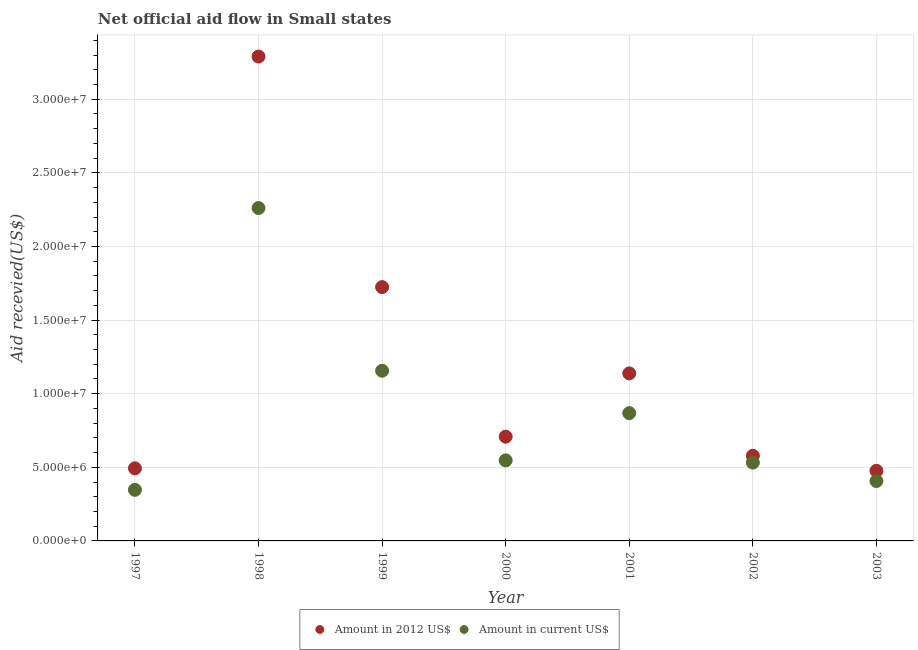Is the number of dotlines equal to the number of legend labels?
Your answer should be compact. Yes. What is the amount of aid received(expressed in us$) in 1998?
Make the answer very short. 2.26e+07. Across all years, what is the maximum amount of aid received(expressed in us$)?
Offer a terse response. 2.26e+07. Across all years, what is the minimum amount of aid received(expressed in 2012 us$)?
Keep it short and to the point. 4.76e+06. What is the total amount of aid received(expressed in 2012 us$) in the graph?
Offer a terse response. 8.41e+07. What is the difference between the amount of aid received(expressed in 2012 us$) in 1999 and that in 2000?
Your response must be concise. 1.02e+07. What is the difference between the amount of aid received(expressed in 2012 us$) in 2003 and the amount of aid received(expressed in us$) in 2001?
Your response must be concise. -3.92e+06. What is the average amount of aid received(expressed in 2012 us$) per year?
Offer a terse response. 1.20e+07. In the year 1997, what is the difference between the amount of aid received(expressed in 2012 us$) and amount of aid received(expressed in us$)?
Your answer should be compact. 1.46e+06. What is the ratio of the amount of aid received(expressed in 2012 us$) in 1997 to that in 2001?
Your response must be concise. 0.43. What is the difference between the highest and the second highest amount of aid received(expressed in us$)?
Your response must be concise. 1.10e+07. What is the difference between the highest and the lowest amount of aid received(expressed in 2012 us$)?
Provide a succinct answer. 2.81e+07. In how many years, is the amount of aid received(expressed in us$) greater than the average amount of aid received(expressed in us$) taken over all years?
Offer a terse response. 2. Does the amount of aid received(expressed in 2012 us$) monotonically increase over the years?
Offer a very short reply. No. Is the amount of aid received(expressed in 2012 us$) strictly greater than the amount of aid received(expressed in us$) over the years?
Give a very brief answer. Yes. Does the graph contain any zero values?
Your answer should be compact. No. Where does the legend appear in the graph?
Provide a succinct answer. Bottom center. How many legend labels are there?
Your answer should be very brief. 2. How are the legend labels stacked?
Offer a terse response. Horizontal. What is the title of the graph?
Your answer should be very brief. Net official aid flow in Small states. Does "External balance on goods" appear as one of the legend labels in the graph?
Offer a very short reply. No. What is the label or title of the X-axis?
Keep it short and to the point. Year. What is the label or title of the Y-axis?
Your response must be concise. Aid recevied(US$). What is the Aid recevied(US$) in Amount in 2012 US$ in 1997?
Your response must be concise. 4.93e+06. What is the Aid recevied(US$) of Amount in current US$ in 1997?
Your answer should be very brief. 3.47e+06. What is the Aid recevied(US$) of Amount in 2012 US$ in 1998?
Ensure brevity in your answer.  3.29e+07. What is the Aid recevied(US$) of Amount in current US$ in 1998?
Your answer should be very brief. 2.26e+07. What is the Aid recevied(US$) of Amount in 2012 US$ in 1999?
Provide a short and direct response. 1.72e+07. What is the Aid recevied(US$) in Amount in current US$ in 1999?
Give a very brief answer. 1.16e+07. What is the Aid recevied(US$) in Amount in 2012 US$ in 2000?
Offer a terse response. 7.08e+06. What is the Aid recevied(US$) of Amount in current US$ in 2000?
Make the answer very short. 5.47e+06. What is the Aid recevied(US$) in Amount in 2012 US$ in 2001?
Offer a terse response. 1.14e+07. What is the Aid recevied(US$) of Amount in current US$ in 2001?
Ensure brevity in your answer.  8.68e+06. What is the Aid recevied(US$) in Amount in 2012 US$ in 2002?
Your answer should be very brief. 5.78e+06. What is the Aid recevied(US$) in Amount in current US$ in 2002?
Ensure brevity in your answer.  5.32e+06. What is the Aid recevied(US$) in Amount in 2012 US$ in 2003?
Your answer should be compact. 4.76e+06. What is the Aid recevied(US$) in Amount in current US$ in 2003?
Your response must be concise. 4.07e+06. Across all years, what is the maximum Aid recevied(US$) in Amount in 2012 US$?
Keep it short and to the point. 3.29e+07. Across all years, what is the maximum Aid recevied(US$) in Amount in current US$?
Offer a very short reply. 2.26e+07. Across all years, what is the minimum Aid recevied(US$) in Amount in 2012 US$?
Your response must be concise. 4.76e+06. Across all years, what is the minimum Aid recevied(US$) in Amount in current US$?
Give a very brief answer. 3.47e+06. What is the total Aid recevied(US$) of Amount in 2012 US$ in the graph?
Offer a terse response. 8.41e+07. What is the total Aid recevied(US$) of Amount in current US$ in the graph?
Your response must be concise. 6.12e+07. What is the difference between the Aid recevied(US$) in Amount in 2012 US$ in 1997 and that in 1998?
Offer a terse response. -2.80e+07. What is the difference between the Aid recevied(US$) in Amount in current US$ in 1997 and that in 1998?
Provide a succinct answer. -1.91e+07. What is the difference between the Aid recevied(US$) in Amount in 2012 US$ in 1997 and that in 1999?
Give a very brief answer. -1.23e+07. What is the difference between the Aid recevied(US$) in Amount in current US$ in 1997 and that in 1999?
Provide a short and direct response. -8.09e+06. What is the difference between the Aid recevied(US$) in Amount in 2012 US$ in 1997 and that in 2000?
Offer a terse response. -2.15e+06. What is the difference between the Aid recevied(US$) in Amount in current US$ in 1997 and that in 2000?
Offer a very short reply. -2.00e+06. What is the difference between the Aid recevied(US$) in Amount in 2012 US$ in 1997 and that in 2001?
Give a very brief answer. -6.45e+06. What is the difference between the Aid recevied(US$) in Amount in current US$ in 1997 and that in 2001?
Ensure brevity in your answer.  -5.21e+06. What is the difference between the Aid recevied(US$) in Amount in 2012 US$ in 1997 and that in 2002?
Keep it short and to the point. -8.50e+05. What is the difference between the Aid recevied(US$) of Amount in current US$ in 1997 and that in 2002?
Ensure brevity in your answer.  -1.85e+06. What is the difference between the Aid recevied(US$) of Amount in 2012 US$ in 1997 and that in 2003?
Keep it short and to the point. 1.70e+05. What is the difference between the Aid recevied(US$) in Amount in current US$ in 1997 and that in 2003?
Your answer should be very brief. -6.00e+05. What is the difference between the Aid recevied(US$) in Amount in 2012 US$ in 1998 and that in 1999?
Provide a short and direct response. 1.57e+07. What is the difference between the Aid recevied(US$) in Amount in current US$ in 1998 and that in 1999?
Your answer should be very brief. 1.10e+07. What is the difference between the Aid recevied(US$) of Amount in 2012 US$ in 1998 and that in 2000?
Offer a very short reply. 2.58e+07. What is the difference between the Aid recevied(US$) in Amount in current US$ in 1998 and that in 2000?
Your answer should be very brief. 1.71e+07. What is the difference between the Aid recevied(US$) in Amount in 2012 US$ in 1998 and that in 2001?
Keep it short and to the point. 2.15e+07. What is the difference between the Aid recevied(US$) of Amount in current US$ in 1998 and that in 2001?
Keep it short and to the point. 1.39e+07. What is the difference between the Aid recevied(US$) of Amount in 2012 US$ in 1998 and that in 2002?
Make the answer very short. 2.71e+07. What is the difference between the Aid recevied(US$) of Amount in current US$ in 1998 and that in 2002?
Provide a short and direct response. 1.73e+07. What is the difference between the Aid recevied(US$) in Amount in 2012 US$ in 1998 and that in 2003?
Your answer should be very brief. 2.81e+07. What is the difference between the Aid recevied(US$) of Amount in current US$ in 1998 and that in 2003?
Give a very brief answer. 1.85e+07. What is the difference between the Aid recevied(US$) in Amount in 2012 US$ in 1999 and that in 2000?
Give a very brief answer. 1.02e+07. What is the difference between the Aid recevied(US$) of Amount in current US$ in 1999 and that in 2000?
Your answer should be very brief. 6.09e+06. What is the difference between the Aid recevied(US$) of Amount in 2012 US$ in 1999 and that in 2001?
Your answer should be compact. 5.86e+06. What is the difference between the Aid recevied(US$) in Amount in current US$ in 1999 and that in 2001?
Your answer should be very brief. 2.88e+06. What is the difference between the Aid recevied(US$) in Amount in 2012 US$ in 1999 and that in 2002?
Offer a terse response. 1.15e+07. What is the difference between the Aid recevied(US$) of Amount in current US$ in 1999 and that in 2002?
Keep it short and to the point. 6.24e+06. What is the difference between the Aid recevied(US$) of Amount in 2012 US$ in 1999 and that in 2003?
Ensure brevity in your answer.  1.25e+07. What is the difference between the Aid recevied(US$) in Amount in current US$ in 1999 and that in 2003?
Your answer should be compact. 7.49e+06. What is the difference between the Aid recevied(US$) of Amount in 2012 US$ in 2000 and that in 2001?
Make the answer very short. -4.30e+06. What is the difference between the Aid recevied(US$) in Amount in current US$ in 2000 and that in 2001?
Keep it short and to the point. -3.21e+06. What is the difference between the Aid recevied(US$) in Amount in 2012 US$ in 2000 and that in 2002?
Provide a short and direct response. 1.30e+06. What is the difference between the Aid recevied(US$) of Amount in 2012 US$ in 2000 and that in 2003?
Your answer should be compact. 2.32e+06. What is the difference between the Aid recevied(US$) in Amount in current US$ in 2000 and that in 2003?
Offer a very short reply. 1.40e+06. What is the difference between the Aid recevied(US$) of Amount in 2012 US$ in 2001 and that in 2002?
Your response must be concise. 5.60e+06. What is the difference between the Aid recevied(US$) in Amount in current US$ in 2001 and that in 2002?
Provide a succinct answer. 3.36e+06. What is the difference between the Aid recevied(US$) of Amount in 2012 US$ in 2001 and that in 2003?
Provide a short and direct response. 6.62e+06. What is the difference between the Aid recevied(US$) in Amount in current US$ in 2001 and that in 2003?
Provide a succinct answer. 4.61e+06. What is the difference between the Aid recevied(US$) of Amount in 2012 US$ in 2002 and that in 2003?
Offer a terse response. 1.02e+06. What is the difference between the Aid recevied(US$) in Amount in current US$ in 2002 and that in 2003?
Provide a succinct answer. 1.25e+06. What is the difference between the Aid recevied(US$) of Amount in 2012 US$ in 1997 and the Aid recevied(US$) of Amount in current US$ in 1998?
Offer a very short reply. -1.77e+07. What is the difference between the Aid recevied(US$) in Amount in 2012 US$ in 1997 and the Aid recevied(US$) in Amount in current US$ in 1999?
Offer a terse response. -6.63e+06. What is the difference between the Aid recevied(US$) in Amount in 2012 US$ in 1997 and the Aid recevied(US$) in Amount in current US$ in 2000?
Make the answer very short. -5.40e+05. What is the difference between the Aid recevied(US$) of Amount in 2012 US$ in 1997 and the Aid recevied(US$) of Amount in current US$ in 2001?
Keep it short and to the point. -3.75e+06. What is the difference between the Aid recevied(US$) in Amount in 2012 US$ in 1997 and the Aid recevied(US$) in Amount in current US$ in 2002?
Make the answer very short. -3.90e+05. What is the difference between the Aid recevied(US$) in Amount in 2012 US$ in 1997 and the Aid recevied(US$) in Amount in current US$ in 2003?
Your answer should be very brief. 8.60e+05. What is the difference between the Aid recevied(US$) in Amount in 2012 US$ in 1998 and the Aid recevied(US$) in Amount in current US$ in 1999?
Your answer should be very brief. 2.13e+07. What is the difference between the Aid recevied(US$) of Amount in 2012 US$ in 1998 and the Aid recevied(US$) of Amount in current US$ in 2000?
Offer a terse response. 2.74e+07. What is the difference between the Aid recevied(US$) of Amount in 2012 US$ in 1998 and the Aid recevied(US$) of Amount in current US$ in 2001?
Provide a short and direct response. 2.42e+07. What is the difference between the Aid recevied(US$) of Amount in 2012 US$ in 1998 and the Aid recevied(US$) of Amount in current US$ in 2002?
Make the answer very short. 2.76e+07. What is the difference between the Aid recevied(US$) of Amount in 2012 US$ in 1998 and the Aid recevied(US$) of Amount in current US$ in 2003?
Offer a very short reply. 2.88e+07. What is the difference between the Aid recevied(US$) of Amount in 2012 US$ in 1999 and the Aid recevied(US$) of Amount in current US$ in 2000?
Keep it short and to the point. 1.18e+07. What is the difference between the Aid recevied(US$) in Amount in 2012 US$ in 1999 and the Aid recevied(US$) in Amount in current US$ in 2001?
Keep it short and to the point. 8.56e+06. What is the difference between the Aid recevied(US$) in Amount in 2012 US$ in 1999 and the Aid recevied(US$) in Amount in current US$ in 2002?
Offer a very short reply. 1.19e+07. What is the difference between the Aid recevied(US$) of Amount in 2012 US$ in 1999 and the Aid recevied(US$) of Amount in current US$ in 2003?
Provide a succinct answer. 1.32e+07. What is the difference between the Aid recevied(US$) of Amount in 2012 US$ in 2000 and the Aid recevied(US$) of Amount in current US$ in 2001?
Keep it short and to the point. -1.60e+06. What is the difference between the Aid recevied(US$) of Amount in 2012 US$ in 2000 and the Aid recevied(US$) of Amount in current US$ in 2002?
Provide a succinct answer. 1.76e+06. What is the difference between the Aid recevied(US$) in Amount in 2012 US$ in 2000 and the Aid recevied(US$) in Amount in current US$ in 2003?
Your answer should be very brief. 3.01e+06. What is the difference between the Aid recevied(US$) in Amount in 2012 US$ in 2001 and the Aid recevied(US$) in Amount in current US$ in 2002?
Provide a succinct answer. 6.06e+06. What is the difference between the Aid recevied(US$) of Amount in 2012 US$ in 2001 and the Aid recevied(US$) of Amount in current US$ in 2003?
Offer a very short reply. 7.31e+06. What is the difference between the Aid recevied(US$) in Amount in 2012 US$ in 2002 and the Aid recevied(US$) in Amount in current US$ in 2003?
Offer a terse response. 1.71e+06. What is the average Aid recevied(US$) of Amount in 2012 US$ per year?
Your response must be concise. 1.20e+07. What is the average Aid recevied(US$) in Amount in current US$ per year?
Ensure brevity in your answer.  8.74e+06. In the year 1997, what is the difference between the Aid recevied(US$) of Amount in 2012 US$ and Aid recevied(US$) of Amount in current US$?
Offer a terse response. 1.46e+06. In the year 1998, what is the difference between the Aid recevied(US$) in Amount in 2012 US$ and Aid recevied(US$) in Amount in current US$?
Provide a short and direct response. 1.03e+07. In the year 1999, what is the difference between the Aid recevied(US$) in Amount in 2012 US$ and Aid recevied(US$) in Amount in current US$?
Keep it short and to the point. 5.68e+06. In the year 2000, what is the difference between the Aid recevied(US$) of Amount in 2012 US$ and Aid recevied(US$) of Amount in current US$?
Ensure brevity in your answer.  1.61e+06. In the year 2001, what is the difference between the Aid recevied(US$) of Amount in 2012 US$ and Aid recevied(US$) of Amount in current US$?
Make the answer very short. 2.70e+06. In the year 2003, what is the difference between the Aid recevied(US$) of Amount in 2012 US$ and Aid recevied(US$) of Amount in current US$?
Give a very brief answer. 6.90e+05. What is the ratio of the Aid recevied(US$) in Amount in 2012 US$ in 1997 to that in 1998?
Offer a terse response. 0.15. What is the ratio of the Aid recevied(US$) in Amount in current US$ in 1997 to that in 1998?
Make the answer very short. 0.15. What is the ratio of the Aid recevied(US$) in Amount in 2012 US$ in 1997 to that in 1999?
Your answer should be very brief. 0.29. What is the ratio of the Aid recevied(US$) of Amount in current US$ in 1997 to that in 1999?
Ensure brevity in your answer.  0.3. What is the ratio of the Aid recevied(US$) of Amount in 2012 US$ in 1997 to that in 2000?
Provide a short and direct response. 0.7. What is the ratio of the Aid recevied(US$) in Amount in current US$ in 1997 to that in 2000?
Provide a short and direct response. 0.63. What is the ratio of the Aid recevied(US$) of Amount in 2012 US$ in 1997 to that in 2001?
Your answer should be very brief. 0.43. What is the ratio of the Aid recevied(US$) of Amount in current US$ in 1997 to that in 2001?
Your answer should be compact. 0.4. What is the ratio of the Aid recevied(US$) in Amount in 2012 US$ in 1997 to that in 2002?
Your response must be concise. 0.85. What is the ratio of the Aid recevied(US$) of Amount in current US$ in 1997 to that in 2002?
Give a very brief answer. 0.65. What is the ratio of the Aid recevied(US$) of Amount in 2012 US$ in 1997 to that in 2003?
Ensure brevity in your answer.  1.04. What is the ratio of the Aid recevied(US$) of Amount in current US$ in 1997 to that in 2003?
Offer a very short reply. 0.85. What is the ratio of the Aid recevied(US$) of Amount in 2012 US$ in 1998 to that in 1999?
Provide a short and direct response. 1.91. What is the ratio of the Aid recevied(US$) in Amount in current US$ in 1998 to that in 1999?
Your answer should be compact. 1.96. What is the ratio of the Aid recevied(US$) in Amount in 2012 US$ in 1998 to that in 2000?
Keep it short and to the point. 4.65. What is the ratio of the Aid recevied(US$) of Amount in current US$ in 1998 to that in 2000?
Make the answer very short. 4.13. What is the ratio of the Aid recevied(US$) in Amount in 2012 US$ in 1998 to that in 2001?
Provide a succinct answer. 2.89. What is the ratio of the Aid recevied(US$) of Amount in current US$ in 1998 to that in 2001?
Provide a short and direct response. 2.6. What is the ratio of the Aid recevied(US$) in Amount in 2012 US$ in 1998 to that in 2002?
Your answer should be compact. 5.69. What is the ratio of the Aid recevied(US$) of Amount in current US$ in 1998 to that in 2002?
Offer a very short reply. 4.25. What is the ratio of the Aid recevied(US$) of Amount in 2012 US$ in 1998 to that in 2003?
Ensure brevity in your answer.  6.91. What is the ratio of the Aid recevied(US$) in Amount in current US$ in 1998 to that in 2003?
Provide a short and direct response. 5.56. What is the ratio of the Aid recevied(US$) of Amount in 2012 US$ in 1999 to that in 2000?
Your answer should be compact. 2.44. What is the ratio of the Aid recevied(US$) of Amount in current US$ in 1999 to that in 2000?
Ensure brevity in your answer.  2.11. What is the ratio of the Aid recevied(US$) in Amount in 2012 US$ in 1999 to that in 2001?
Ensure brevity in your answer.  1.51. What is the ratio of the Aid recevied(US$) in Amount in current US$ in 1999 to that in 2001?
Make the answer very short. 1.33. What is the ratio of the Aid recevied(US$) of Amount in 2012 US$ in 1999 to that in 2002?
Offer a terse response. 2.98. What is the ratio of the Aid recevied(US$) of Amount in current US$ in 1999 to that in 2002?
Offer a very short reply. 2.17. What is the ratio of the Aid recevied(US$) in Amount in 2012 US$ in 1999 to that in 2003?
Keep it short and to the point. 3.62. What is the ratio of the Aid recevied(US$) of Amount in current US$ in 1999 to that in 2003?
Provide a short and direct response. 2.84. What is the ratio of the Aid recevied(US$) in Amount in 2012 US$ in 2000 to that in 2001?
Keep it short and to the point. 0.62. What is the ratio of the Aid recevied(US$) in Amount in current US$ in 2000 to that in 2001?
Offer a terse response. 0.63. What is the ratio of the Aid recevied(US$) in Amount in 2012 US$ in 2000 to that in 2002?
Offer a terse response. 1.22. What is the ratio of the Aid recevied(US$) of Amount in current US$ in 2000 to that in 2002?
Offer a terse response. 1.03. What is the ratio of the Aid recevied(US$) of Amount in 2012 US$ in 2000 to that in 2003?
Keep it short and to the point. 1.49. What is the ratio of the Aid recevied(US$) of Amount in current US$ in 2000 to that in 2003?
Offer a very short reply. 1.34. What is the ratio of the Aid recevied(US$) of Amount in 2012 US$ in 2001 to that in 2002?
Provide a succinct answer. 1.97. What is the ratio of the Aid recevied(US$) in Amount in current US$ in 2001 to that in 2002?
Make the answer very short. 1.63. What is the ratio of the Aid recevied(US$) in Amount in 2012 US$ in 2001 to that in 2003?
Give a very brief answer. 2.39. What is the ratio of the Aid recevied(US$) of Amount in current US$ in 2001 to that in 2003?
Provide a succinct answer. 2.13. What is the ratio of the Aid recevied(US$) in Amount in 2012 US$ in 2002 to that in 2003?
Your answer should be compact. 1.21. What is the ratio of the Aid recevied(US$) of Amount in current US$ in 2002 to that in 2003?
Ensure brevity in your answer.  1.31. What is the difference between the highest and the second highest Aid recevied(US$) of Amount in 2012 US$?
Your response must be concise. 1.57e+07. What is the difference between the highest and the second highest Aid recevied(US$) in Amount in current US$?
Ensure brevity in your answer.  1.10e+07. What is the difference between the highest and the lowest Aid recevied(US$) in Amount in 2012 US$?
Offer a terse response. 2.81e+07. What is the difference between the highest and the lowest Aid recevied(US$) in Amount in current US$?
Your response must be concise. 1.91e+07. 